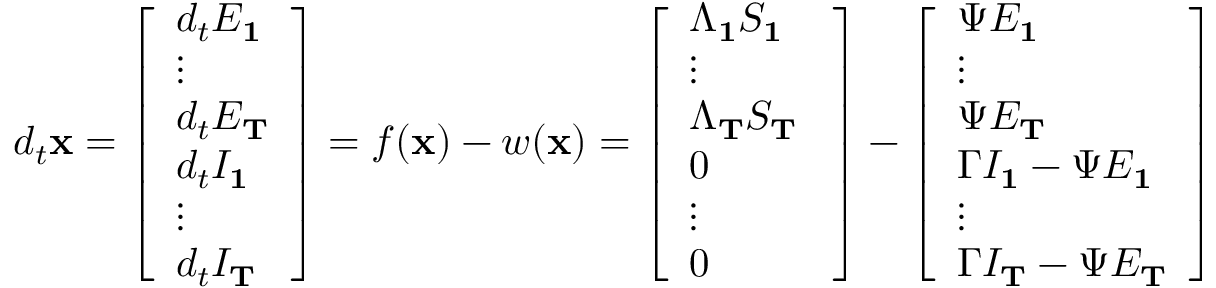<formula> <loc_0><loc_0><loc_500><loc_500>d _ { t } x = \left [ \begin{array} { l } { d _ { t } E _ { 1 } } \\ { \vdots } \\ { d _ { t } E _ { T } } \\ { d _ { t } I _ { 1 } } \\ { \vdots } \\ { d _ { t } I _ { T } } \end{array} \right ] = f ( x ) - w ( x ) = \left [ \begin{array} { l } { \Lambda _ { 1 } S _ { 1 } } \\ { \vdots } \\ { \Lambda _ { T } S _ { T } \ } \\ { 0 } \\ { \vdots } \\ { 0 } \end{array} \right ] - \left [ \begin{array} { l } { \Psi E _ { 1 } } \\ { \vdots } \\ { \Psi E _ { T } } \\ { \Gamma I _ { 1 } - \Psi E _ { 1 } } \\ { \vdots } \\ { \Gamma I _ { T } - \Psi E _ { T } } \end{array} \right ]</formula> 